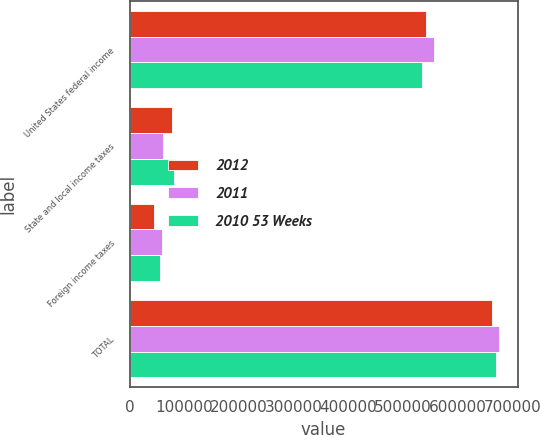Convert chart. <chart><loc_0><loc_0><loc_500><loc_500><stacked_bar_chart><ecel><fcel>United States federal income<fcel>State and local income taxes<fcel>Foreign income taxes<fcel>TOTAL<nl><fcel>2012<fcel>540861<fcel>77064<fcel>44492<fcel>662417<nl><fcel>2011<fcel>556663<fcel>60081<fcel>58680<fcel>675424<nl><fcel>2010 53 Weeks<fcel>533832<fcel>80492<fcel>55282<fcel>669606<nl></chart> 